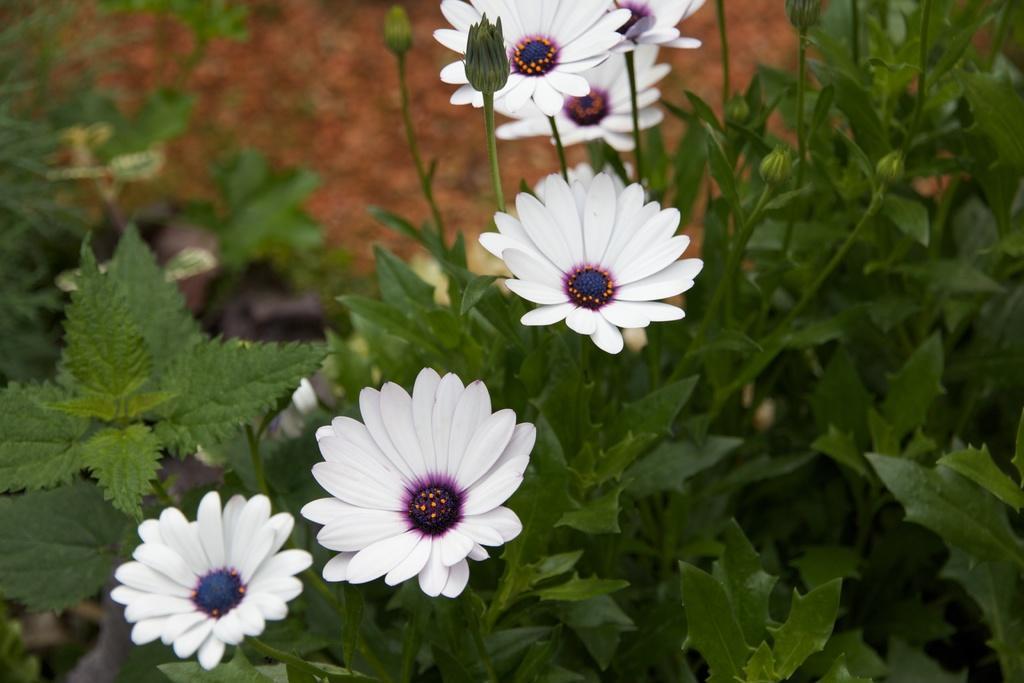Could you give a brief overview of what you see in this image? In this image we can see white color flowers, stems and leaves. 